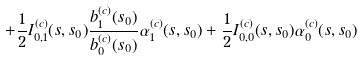Convert formula to latex. <formula><loc_0><loc_0><loc_500><loc_500>+ \frac { 1 } { 2 } I _ { 0 , 1 } ^ { ( c ) } ( s , s _ { 0 } ) \frac { b _ { 1 } ^ { ( c ) } ( s _ { 0 } ) } { b _ { 0 } ^ { ( c ) } ( s _ { 0 } ) } { \alpha } _ { 1 } ^ { ( c ) } ( s , s _ { 0 } ) + \frac { 1 } { 2 } I _ { 0 , 0 } ^ { ( c ) } ( s , s _ { 0 } ) { \alpha } _ { 0 } ^ { ( c ) } ( s , s _ { 0 } )</formula> 